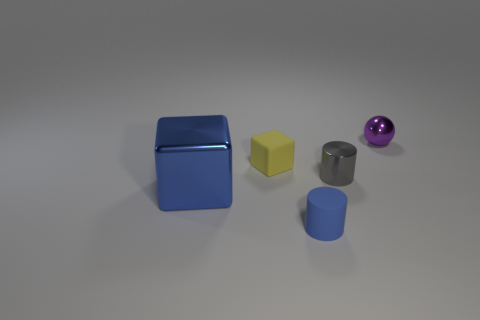What number of other things are made of the same material as the small yellow cube?
Your response must be concise. 1. There is a small matte object in front of the blue thing that is behind the tiny blue rubber object; what shape is it?
Keep it short and to the point. Cylinder. What number of things are large red spheres or small things that are behind the blue cylinder?
Your answer should be very brief. 3. How many other things are there of the same color as the large object?
Keep it short and to the point. 1. What number of yellow objects are either big blocks or rubber cubes?
Keep it short and to the point. 1. There is a tiny rubber thing that is on the right side of the yellow matte block that is to the left of the gray object; are there any small cylinders behind it?
Offer a terse response. Yes. Is there any other thing that has the same size as the metallic cube?
Your response must be concise. No. Do the metal block and the matte cylinder have the same color?
Offer a very short reply. Yes. What color is the rubber thing in front of the matte object behind the tiny gray shiny object?
Your response must be concise. Blue. What number of small objects are either metal objects or blue things?
Give a very brief answer. 3. 